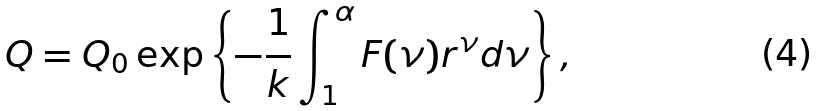<formula> <loc_0><loc_0><loc_500><loc_500>Q = Q _ { 0 } \exp \left \{ - \frac { 1 } { k } \int ^ { \alpha } _ { 1 } F ( \nu ) r ^ { \nu } d \nu \right \} ,</formula> 